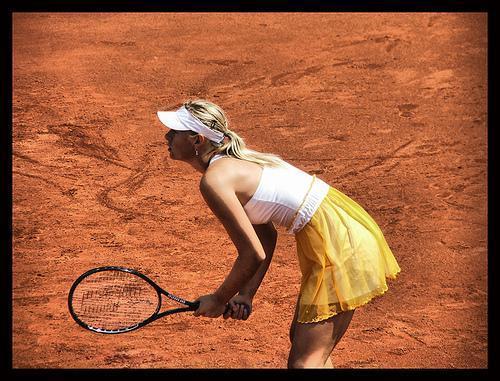How many people are in this photo?
Give a very brief answer. 1. How many hands is she using to hold the tennis racket?
Give a very brief answer. 2. How many cars are there with yellow color?
Give a very brief answer. 0. 